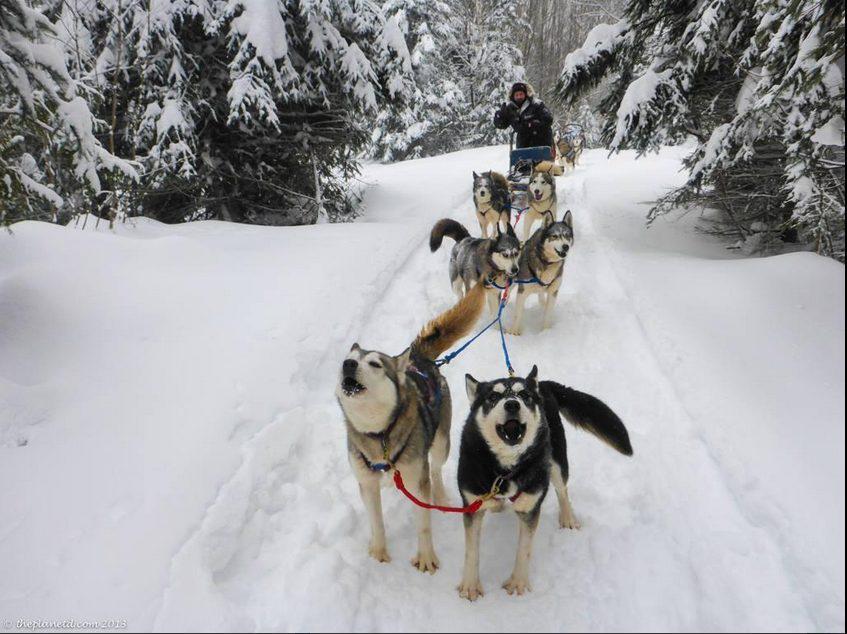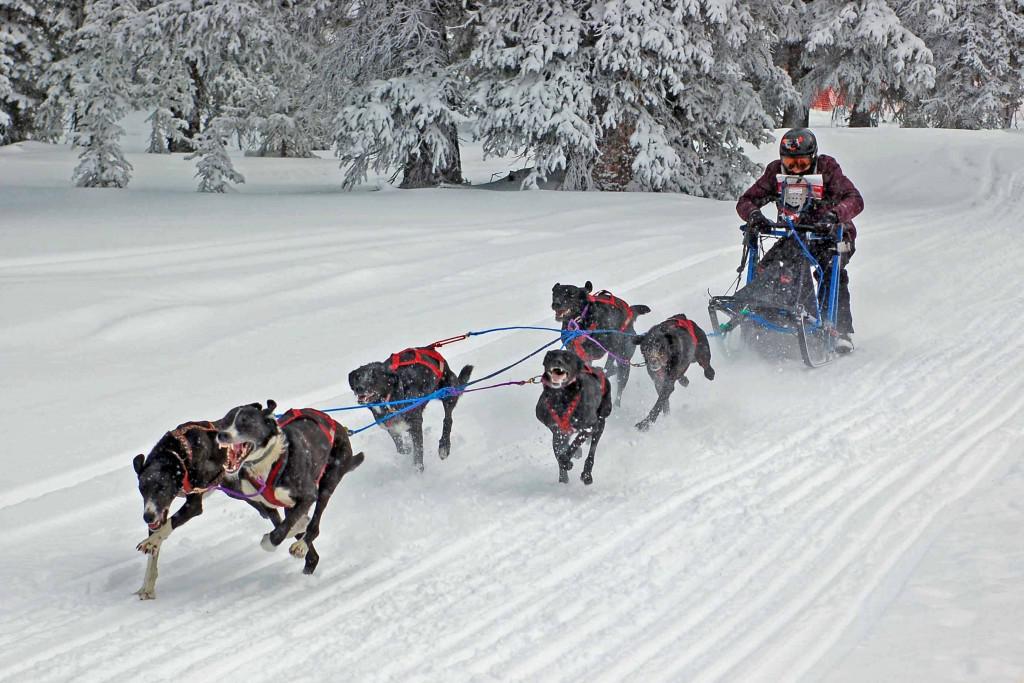The first image is the image on the left, the second image is the image on the right. Examine the images to the left and right. Is the description "All of the dogs are standing and at least some of the dogs are running." accurate? Answer yes or no. Yes. The first image is the image on the left, the second image is the image on the right. Given the left and right images, does the statement "There is a person with a red coat in one of the images." hold true? Answer yes or no. No. 